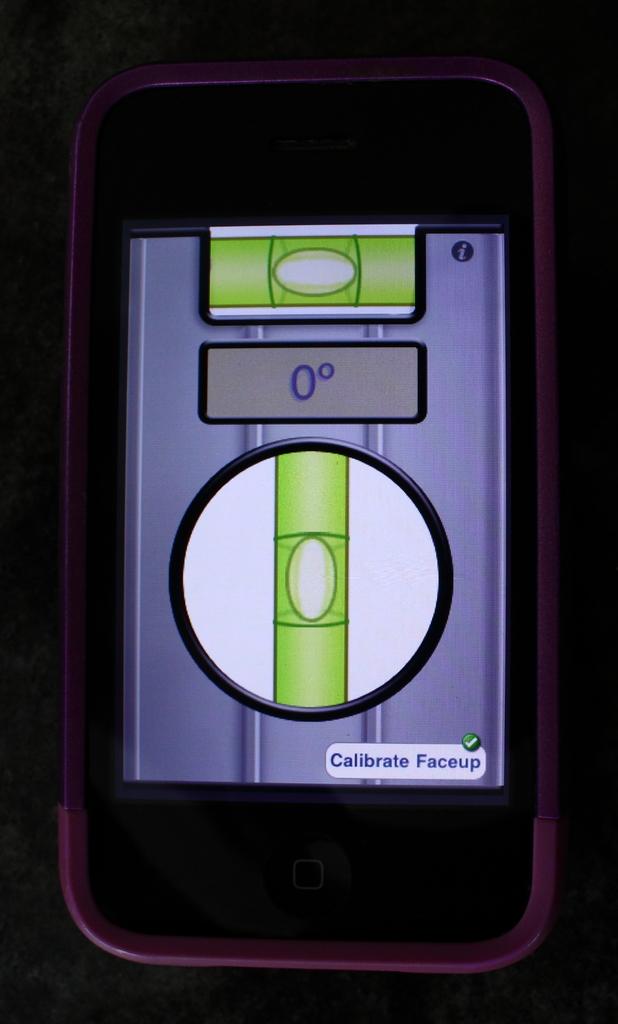What is written on the top right hand corner of the page?
Your answer should be very brief. I. This is mobile?
Offer a very short reply. Answering does not require reading text in the image. 